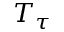<formula> <loc_0><loc_0><loc_500><loc_500>T _ { \tau }</formula> 